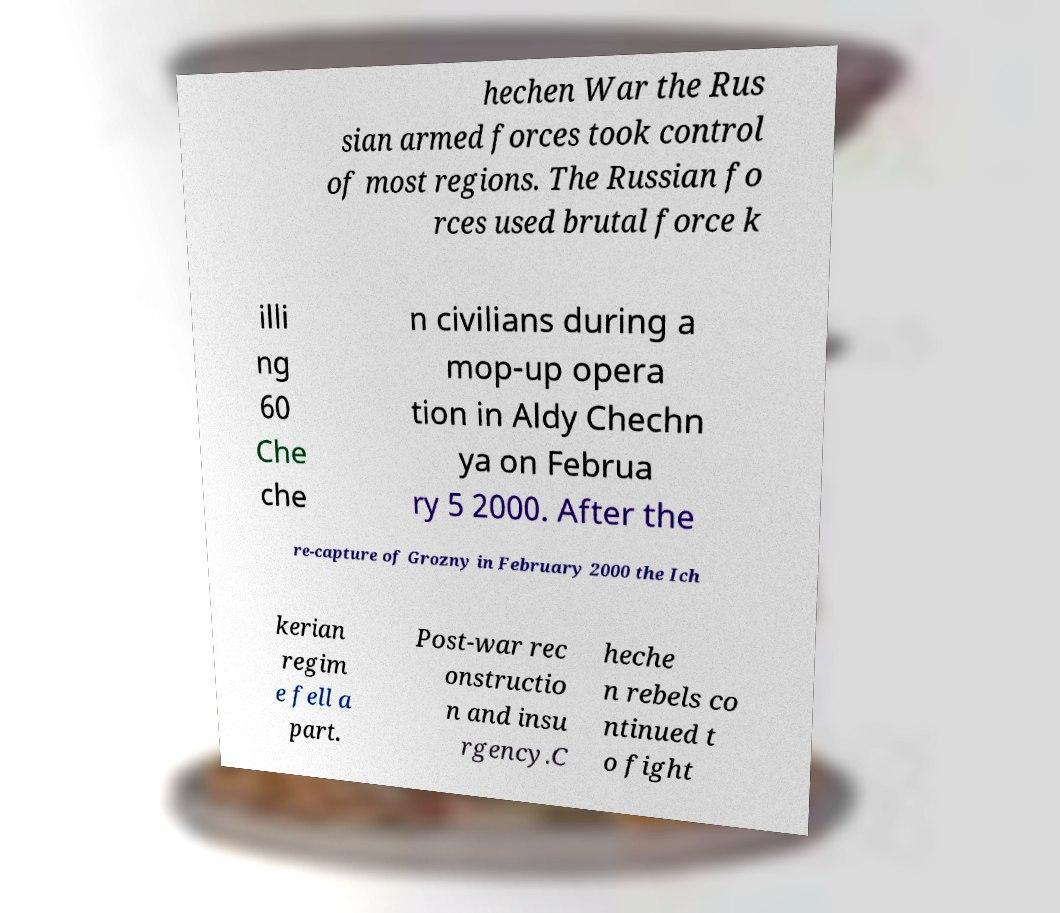Can you accurately transcribe the text from the provided image for me? hechen War the Rus sian armed forces took control of most regions. The Russian fo rces used brutal force k illi ng 60 Che che n civilians during a mop-up opera tion in Aldy Chechn ya on Februa ry 5 2000. After the re-capture of Grozny in February 2000 the Ich kerian regim e fell a part. Post-war rec onstructio n and insu rgency.C heche n rebels co ntinued t o fight 